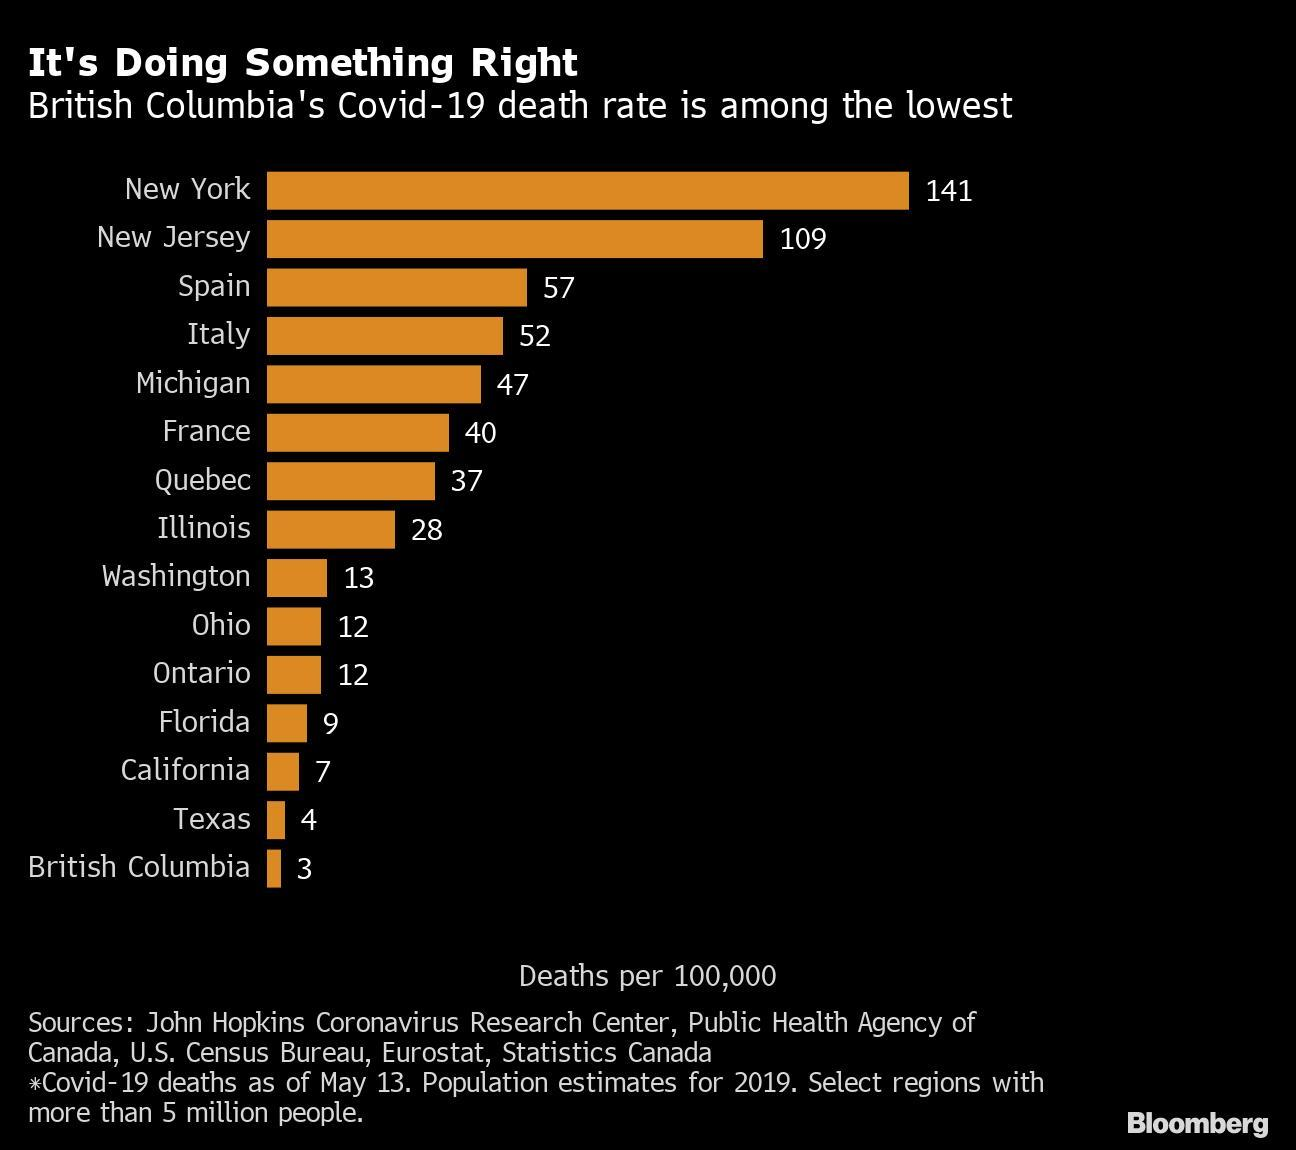What is the Covid-19 death rate in France as of May 13?
Answer the question with a short phrase. 40 What is the Covid-19 death rate in Spain as of May 13? 57 Which US state has reported the second-highest Covid-19 death rate among the selected regions as of May 13? New Jersey 